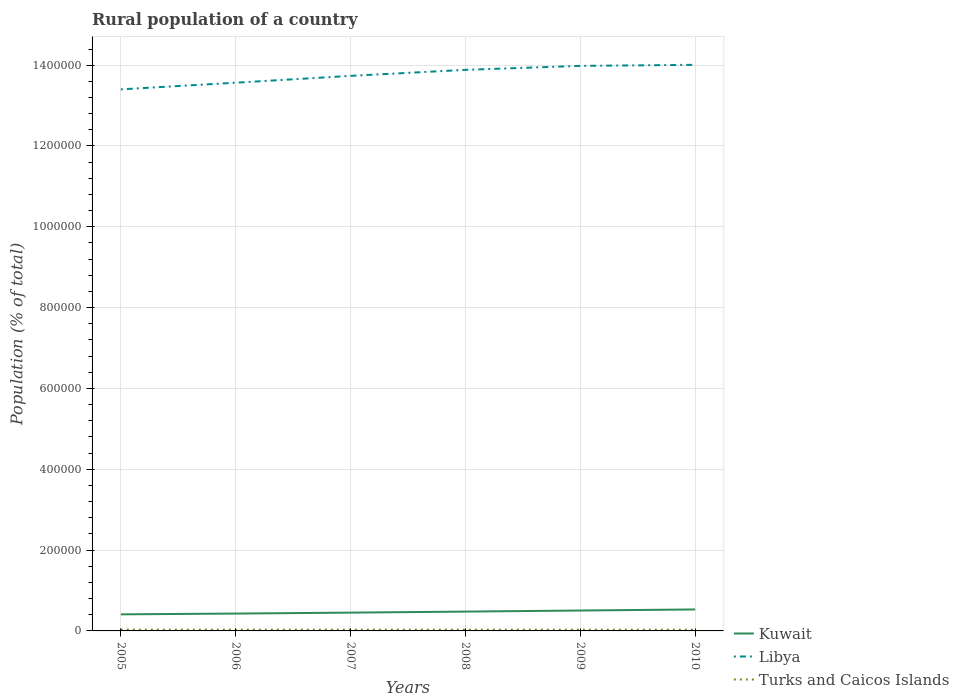How many different coloured lines are there?
Make the answer very short. 3. Is the number of lines equal to the number of legend labels?
Provide a succinct answer. Yes. Across all years, what is the maximum rural population in Libya?
Your answer should be very brief. 1.34e+06. In which year was the rural population in Kuwait maximum?
Your answer should be compact. 2005. What is the total rural population in Libya in the graph?
Your response must be concise. -3.18e+04. What is the difference between the highest and the second highest rural population in Kuwait?
Give a very brief answer. 1.21e+04. What is the difference between the highest and the lowest rural population in Turks and Caicos Islands?
Give a very brief answer. 3. How many lines are there?
Ensure brevity in your answer.  3. How many years are there in the graph?
Make the answer very short. 6. What is the difference between two consecutive major ticks on the Y-axis?
Provide a short and direct response. 2.00e+05. What is the title of the graph?
Give a very brief answer. Rural population of a country. What is the label or title of the X-axis?
Give a very brief answer. Years. What is the label or title of the Y-axis?
Provide a succinct answer. Population (% of total). What is the Population (% of total) in Kuwait in 2005?
Offer a very short reply. 4.10e+04. What is the Population (% of total) in Libya in 2005?
Ensure brevity in your answer.  1.34e+06. What is the Population (% of total) of Turks and Caicos Islands in 2005?
Provide a succinct answer. 3241. What is the Population (% of total) in Kuwait in 2006?
Ensure brevity in your answer.  4.30e+04. What is the Population (% of total) in Libya in 2006?
Keep it short and to the point. 1.36e+06. What is the Population (% of total) in Turks and Caicos Islands in 2006?
Ensure brevity in your answer.  3239. What is the Population (% of total) of Kuwait in 2007?
Give a very brief answer. 4.53e+04. What is the Population (% of total) in Libya in 2007?
Ensure brevity in your answer.  1.37e+06. What is the Population (% of total) in Turks and Caicos Islands in 2007?
Your answer should be very brief. 3208. What is the Population (% of total) of Kuwait in 2008?
Keep it short and to the point. 4.78e+04. What is the Population (% of total) in Libya in 2008?
Your response must be concise. 1.39e+06. What is the Population (% of total) in Turks and Caicos Islands in 2008?
Offer a terse response. 3156. What is the Population (% of total) in Kuwait in 2009?
Your response must be concise. 5.05e+04. What is the Population (% of total) in Libya in 2009?
Provide a succinct answer. 1.40e+06. What is the Population (% of total) in Turks and Caicos Islands in 2009?
Provide a short and direct response. 3094. What is the Population (% of total) of Kuwait in 2010?
Offer a very short reply. 5.31e+04. What is the Population (% of total) of Libya in 2010?
Your response must be concise. 1.40e+06. What is the Population (% of total) in Turks and Caicos Islands in 2010?
Ensure brevity in your answer.  3029. Across all years, what is the maximum Population (% of total) of Kuwait?
Offer a very short reply. 5.31e+04. Across all years, what is the maximum Population (% of total) of Libya?
Your response must be concise. 1.40e+06. Across all years, what is the maximum Population (% of total) in Turks and Caicos Islands?
Your answer should be very brief. 3241. Across all years, what is the minimum Population (% of total) in Kuwait?
Offer a terse response. 4.10e+04. Across all years, what is the minimum Population (% of total) of Libya?
Give a very brief answer. 1.34e+06. Across all years, what is the minimum Population (% of total) of Turks and Caicos Islands?
Ensure brevity in your answer.  3029. What is the total Population (% of total) of Kuwait in the graph?
Your response must be concise. 2.81e+05. What is the total Population (% of total) of Libya in the graph?
Your response must be concise. 8.26e+06. What is the total Population (% of total) in Turks and Caicos Islands in the graph?
Give a very brief answer. 1.90e+04. What is the difference between the Population (% of total) of Kuwait in 2005 and that in 2006?
Your response must be concise. -1924. What is the difference between the Population (% of total) of Libya in 2005 and that in 2006?
Ensure brevity in your answer.  -1.65e+04. What is the difference between the Population (% of total) in Kuwait in 2005 and that in 2007?
Provide a short and direct response. -4224. What is the difference between the Population (% of total) in Libya in 2005 and that in 2007?
Your answer should be compact. -3.34e+04. What is the difference between the Population (% of total) of Kuwait in 2005 and that in 2008?
Give a very brief answer. -6791. What is the difference between the Population (% of total) in Libya in 2005 and that in 2008?
Provide a short and direct response. -4.83e+04. What is the difference between the Population (% of total) in Turks and Caicos Islands in 2005 and that in 2008?
Give a very brief answer. 85. What is the difference between the Population (% of total) in Kuwait in 2005 and that in 2009?
Provide a short and direct response. -9440. What is the difference between the Population (% of total) in Libya in 2005 and that in 2009?
Your answer should be very brief. -5.81e+04. What is the difference between the Population (% of total) in Turks and Caicos Islands in 2005 and that in 2009?
Provide a succinct answer. 147. What is the difference between the Population (% of total) of Kuwait in 2005 and that in 2010?
Provide a short and direct response. -1.21e+04. What is the difference between the Population (% of total) of Libya in 2005 and that in 2010?
Your answer should be compact. -6.07e+04. What is the difference between the Population (% of total) of Turks and Caicos Islands in 2005 and that in 2010?
Offer a terse response. 212. What is the difference between the Population (% of total) in Kuwait in 2006 and that in 2007?
Offer a very short reply. -2300. What is the difference between the Population (% of total) of Libya in 2006 and that in 2007?
Your answer should be very brief. -1.69e+04. What is the difference between the Population (% of total) in Kuwait in 2006 and that in 2008?
Provide a short and direct response. -4867. What is the difference between the Population (% of total) in Libya in 2006 and that in 2008?
Keep it short and to the point. -3.18e+04. What is the difference between the Population (% of total) of Turks and Caicos Islands in 2006 and that in 2008?
Your answer should be very brief. 83. What is the difference between the Population (% of total) of Kuwait in 2006 and that in 2009?
Provide a succinct answer. -7516. What is the difference between the Population (% of total) of Libya in 2006 and that in 2009?
Provide a succinct answer. -4.16e+04. What is the difference between the Population (% of total) in Turks and Caicos Islands in 2006 and that in 2009?
Your answer should be compact. 145. What is the difference between the Population (% of total) of Kuwait in 2006 and that in 2010?
Ensure brevity in your answer.  -1.02e+04. What is the difference between the Population (% of total) in Libya in 2006 and that in 2010?
Offer a terse response. -4.42e+04. What is the difference between the Population (% of total) in Turks and Caicos Islands in 2006 and that in 2010?
Ensure brevity in your answer.  210. What is the difference between the Population (% of total) in Kuwait in 2007 and that in 2008?
Offer a very short reply. -2567. What is the difference between the Population (% of total) in Libya in 2007 and that in 2008?
Your response must be concise. -1.49e+04. What is the difference between the Population (% of total) of Turks and Caicos Islands in 2007 and that in 2008?
Your response must be concise. 52. What is the difference between the Population (% of total) in Kuwait in 2007 and that in 2009?
Make the answer very short. -5216. What is the difference between the Population (% of total) of Libya in 2007 and that in 2009?
Your answer should be very brief. -2.47e+04. What is the difference between the Population (% of total) in Turks and Caicos Islands in 2007 and that in 2009?
Make the answer very short. 114. What is the difference between the Population (% of total) of Kuwait in 2007 and that in 2010?
Ensure brevity in your answer.  -7880. What is the difference between the Population (% of total) of Libya in 2007 and that in 2010?
Keep it short and to the point. -2.73e+04. What is the difference between the Population (% of total) in Turks and Caicos Islands in 2007 and that in 2010?
Provide a short and direct response. 179. What is the difference between the Population (% of total) of Kuwait in 2008 and that in 2009?
Make the answer very short. -2649. What is the difference between the Population (% of total) in Libya in 2008 and that in 2009?
Offer a terse response. -9801. What is the difference between the Population (% of total) of Turks and Caicos Islands in 2008 and that in 2009?
Keep it short and to the point. 62. What is the difference between the Population (% of total) of Kuwait in 2008 and that in 2010?
Offer a very short reply. -5313. What is the difference between the Population (% of total) of Libya in 2008 and that in 2010?
Offer a terse response. -1.24e+04. What is the difference between the Population (% of total) in Turks and Caicos Islands in 2008 and that in 2010?
Offer a very short reply. 127. What is the difference between the Population (% of total) in Kuwait in 2009 and that in 2010?
Offer a terse response. -2664. What is the difference between the Population (% of total) in Libya in 2009 and that in 2010?
Provide a succinct answer. -2628. What is the difference between the Population (% of total) in Kuwait in 2005 and the Population (% of total) in Libya in 2006?
Your answer should be compact. -1.32e+06. What is the difference between the Population (% of total) in Kuwait in 2005 and the Population (% of total) in Turks and Caicos Islands in 2006?
Offer a terse response. 3.78e+04. What is the difference between the Population (% of total) of Libya in 2005 and the Population (% of total) of Turks and Caicos Islands in 2006?
Ensure brevity in your answer.  1.34e+06. What is the difference between the Population (% of total) in Kuwait in 2005 and the Population (% of total) in Libya in 2007?
Offer a terse response. -1.33e+06. What is the difference between the Population (% of total) of Kuwait in 2005 and the Population (% of total) of Turks and Caicos Islands in 2007?
Provide a short and direct response. 3.78e+04. What is the difference between the Population (% of total) in Libya in 2005 and the Population (% of total) in Turks and Caicos Islands in 2007?
Provide a short and direct response. 1.34e+06. What is the difference between the Population (% of total) in Kuwait in 2005 and the Population (% of total) in Libya in 2008?
Offer a very short reply. -1.35e+06. What is the difference between the Population (% of total) in Kuwait in 2005 and the Population (% of total) in Turks and Caicos Islands in 2008?
Keep it short and to the point. 3.79e+04. What is the difference between the Population (% of total) of Libya in 2005 and the Population (% of total) of Turks and Caicos Islands in 2008?
Offer a very short reply. 1.34e+06. What is the difference between the Population (% of total) of Kuwait in 2005 and the Population (% of total) of Libya in 2009?
Provide a succinct answer. -1.36e+06. What is the difference between the Population (% of total) in Kuwait in 2005 and the Population (% of total) in Turks and Caicos Islands in 2009?
Provide a succinct answer. 3.79e+04. What is the difference between the Population (% of total) of Libya in 2005 and the Population (% of total) of Turks and Caicos Islands in 2009?
Provide a succinct answer. 1.34e+06. What is the difference between the Population (% of total) of Kuwait in 2005 and the Population (% of total) of Libya in 2010?
Offer a terse response. -1.36e+06. What is the difference between the Population (% of total) of Kuwait in 2005 and the Population (% of total) of Turks and Caicos Islands in 2010?
Offer a very short reply. 3.80e+04. What is the difference between the Population (% of total) of Libya in 2005 and the Population (% of total) of Turks and Caicos Islands in 2010?
Keep it short and to the point. 1.34e+06. What is the difference between the Population (% of total) in Kuwait in 2006 and the Population (% of total) in Libya in 2007?
Provide a succinct answer. -1.33e+06. What is the difference between the Population (% of total) in Kuwait in 2006 and the Population (% of total) in Turks and Caicos Islands in 2007?
Offer a very short reply. 3.98e+04. What is the difference between the Population (% of total) in Libya in 2006 and the Population (% of total) in Turks and Caicos Islands in 2007?
Offer a very short reply. 1.35e+06. What is the difference between the Population (% of total) of Kuwait in 2006 and the Population (% of total) of Libya in 2008?
Offer a terse response. -1.35e+06. What is the difference between the Population (% of total) in Kuwait in 2006 and the Population (% of total) in Turks and Caicos Islands in 2008?
Offer a terse response. 3.98e+04. What is the difference between the Population (% of total) in Libya in 2006 and the Population (% of total) in Turks and Caicos Islands in 2008?
Your response must be concise. 1.35e+06. What is the difference between the Population (% of total) in Kuwait in 2006 and the Population (% of total) in Libya in 2009?
Your response must be concise. -1.36e+06. What is the difference between the Population (% of total) in Kuwait in 2006 and the Population (% of total) in Turks and Caicos Islands in 2009?
Provide a short and direct response. 3.99e+04. What is the difference between the Population (% of total) in Libya in 2006 and the Population (% of total) in Turks and Caicos Islands in 2009?
Offer a terse response. 1.35e+06. What is the difference between the Population (% of total) in Kuwait in 2006 and the Population (% of total) in Libya in 2010?
Ensure brevity in your answer.  -1.36e+06. What is the difference between the Population (% of total) in Kuwait in 2006 and the Population (% of total) in Turks and Caicos Islands in 2010?
Your answer should be compact. 3.99e+04. What is the difference between the Population (% of total) in Libya in 2006 and the Population (% of total) in Turks and Caicos Islands in 2010?
Your answer should be compact. 1.35e+06. What is the difference between the Population (% of total) of Kuwait in 2007 and the Population (% of total) of Libya in 2008?
Make the answer very short. -1.34e+06. What is the difference between the Population (% of total) in Kuwait in 2007 and the Population (% of total) in Turks and Caicos Islands in 2008?
Offer a very short reply. 4.21e+04. What is the difference between the Population (% of total) of Libya in 2007 and the Population (% of total) of Turks and Caicos Islands in 2008?
Make the answer very short. 1.37e+06. What is the difference between the Population (% of total) in Kuwait in 2007 and the Population (% of total) in Libya in 2009?
Keep it short and to the point. -1.35e+06. What is the difference between the Population (% of total) in Kuwait in 2007 and the Population (% of total) in Turks and Caicos Islands in 2009?
Keep it short and to the point. 4.22e+04. What is the difference between the Population (% of total) in Libya in 2007 and the Population (% of total) in Turks and Caicos Islands in 2009?
Give a very brief answer. 1.37e+06. What is the difference between the Population (% of total) in Kuwait in 2007 and the Population (% of total) in Libya in 2010?
Provide a succinct answer. -1.36e+06. What is the difference between the Population (% of total) in Kuwait in 2007 and the Population (% of total) in Turks and Caicos Islands in 2010?
Your response must be concise. 4.22e+04. What is the difference between the Population (% of total) in Libya in 2007 and the Population (% of total) in Turks and Caicos Islands in 2010?
Offer a terse response. 1.37e+06. What is the difference between the Population (% of total) in Kuwait in 2008 and the Population (% of total) in Libya in 2009?
Keep it short and to the point. -1.35e+06. What is the difference between the Population (% of total) of Kuwait in 2008 and the Population (% of total) of Turks and Caicos Islands in 2009?
Offer a very short reply. 4.47e+04. What is the difference between the Population (% of total) of Libya in 2008 and the Population (% of total) of Turks and Caicos Islands in 2009?
Your answer should be very brief. 1.39e+06. What is the difference between the Population (% of total) of Kuwait in 2008 and the Population (% of total) of Libya in 2010?
Provide a succinct answer. -1.35e+06. What is the difference between the Population (% of total) of Kuwait in 2008 and the Population (% of total) of Turks and Caicos Islands in 2010?
Make the answer very short. 4.48e+04. What is the difference between the Population (% of total) in Libya in 2008 and the Population (% of total) in Turks and Caicos Islands in 2010?
Provide a succinct answer. 1.39e+06. What is the difference between the Population (% of total) of Kuwait in 2009 and the Population (% of total) of Libya in 2010?
Your response must be concise. -1.35e+06. What is the difference between the Population (% of total) in Kuwait in 2009 and the Population (% of total) in Turks and Caicos Islands in 2010?
Ensure brevity in your answer.  4.74e+04. What is the difference between the Population (% of total) of Libya in 2009 and the Population (% of total) of Turks and Caicos Islands in 2010?
Offer a very short reply. 1.40e+06. What is the average Population (% of total) in Kuwait per year?
Make the answer very short. 4.68e+04. What is the average Population (% of total) in Libya per year?
Ensure brevity in your answer.  1.38e+06. What is the average Population (% of total) in Turks and Caicos Islands per year?
Your answer should be compact. 3161.17. In the year 2005, what is the difference between the Population (% of total) in Kuwait and Population (% of total) in Libya?
Make the answer very short. -1.30e+06. In the year 2005, what is the difference between the Population (% of total) of Kuwait and Population (% of total) of Turks and Caicos Islands?
Ensure brevity in your answer.  3.78e+04. In the year 2005, what is the difference between the Population (% of total) in Libya and Population (% of total) in Turks and Caicos Islands?
Your answer should be compact. 1.34e+06. In the year 2006, what is the difference between the Population (% of total) of Kuwait and Population (% of total) of Libya?
Offer a terse response. -1.31e+06. In the year 2006, what is the difference between the Population (% of total) of Kuwait and Population (% of total) of Turks and Caicos Islands?
Provide a succinct answer. 3.97e+04. In the year 2006, what is the difference between the Population (% of total) of Libya and Population (% of total) of Turks and Caicos Islands?
Your answer should be compact. 1.35e+06. In the year 2007, what is the difference between the Population (% of total) of Kuwait and Population (% of total) of Libya?
Your answer should be very brief. -1.33e+06. In the year 2007, what is the difference between the Population (% of total) in Kuwait and Population (% of total) in Turks and Caicos Islands?
Offer a terse response. 4.21e+04. In the year 2007, what is the difference between the Population (% of total) of Libya and Population (% of total) of Turks and Caicos Islands?
Make the answer very short. 1.37e+06. In the year 2008, what is the difference between the Population (% of total) in Kuwait and Population (% of total) in Libya?
Ensure brevity in your answer.  -1.34e+06. In the year 2008, what is the difference between the Population (% of total) in Kuwait and Population (% of total) in Turks and Caicos Islands?
Keep it short and to the point. 4.47e+04. In the year 2008, what is the difference between the Population (% of total) in Libya and Population (% of total) in Turks and Caicos Islands?
Provide a succinct answer. 1.39e+06. In the year 2009, what is the difference between the Population (% of total) in Kuwait and Population (% of total) in Libya?
Ensure brevity in your answer.  -1.35e+06. In the year 2009, what is the difference between the Population (% of total) of Kuwait and Population (% of total) of Turks and Caicos Islands?
Your answer should be compact. 4.74e+04. In the year 2009, what is the difference between the Population (% of total) of Libya and Population (% of total) of Turks and Caicos Islands?
Offer a terse response. 1.40e+06. In the year 2010, what is the difference between the Population (% of total) in Kuwait and Population (% of total) in Libya?
Ensure brevity in your answer.  -1.35e+06. In the year 2010, what is the difference between the Population (% of total) in Kuwait and Population (% of total) in Turks and Caicos Islands?
Your answer should be compact. 5.01e+04. In the year 2010, what is the difference between the Population (% of total) in Libya and Population (% of total) in Turks and Caicos Islands?
Your answer should be compact. 1.40e+06. What is the ratio of the Population (% of total) in Kuwait in 2005 to that in 2006?
Give a very brief answer. 0.96. What is the ratio of the Population (% of total) of Libya in 2005 to that in 2006?
Your response must be concise. 0.99. What is the ratio of the Population (% of total) of Turks and Caicos Islands in 2005 to that in 2006?
Offer a terse response. 1. What is the ratio of the Population (% of total) in Kuwait in 2005 to that in 2007?
Offer a terse response. 0.91. What is the ratio of the Population (% of total) in Libya in 2005 to that in 2007?
Give a very brief answer. 0.98. What is the ratio of the Population (% of total) of Turks and Caicos Islands in 2005 to that in 2007?
Ensure brevity in your answer.  1.01. What is the ratio of the Population (% of total) in Kuwait in 2005 to that in 2008?
Provide a short and direct response. 0.86. What is the ratio of the Population (% of total) in Libya in 2005 to that in 2008?
Offer a very short reply. 0.97. What is the ratio of the Population (% of total) in Turks and Caicos Islands in 2005 to that in 2008?
Make the answer very short. 1.03. What is the ratio of the Population (% of total) in Kuwait in 2005 to that in 2009?
Offer a very short reply. 0.81. What is the ratio of the Population (% of total) in Libya in 2005 to that in 2009?
Offer a terse response. 0.96. What is the ratio of the Population (% of total) in Turks and Caicos Islands in 2005 to that in 2009?
Ensure brevity in your answer.  1.05. What is the ratio of the Population (% of total) of Kuwait in 2005 to that in 2010?
Provide a short and direct response. 0.77. What is the ratio of the Population (% of total) of Libya in 2005 to that in 2010?
Your response must be concise. 0.96. What is the ratio of the Population (% of total) in Turks and Caicos Islands in 2005 to that in 2010?
Offer a very short reply. 1.07. What is the ratio of the Population (% of total) of Kuwait in 2006 to that in 2007?
Your answer should be compact. 0.95. What is the ratio of the Population (% of total) of Turks and Caicos Islands in 2006 to that in 2007?
Your answer should be compact. 1.01. What is the ratio of the Population (% of total) of Kuwait in 2006 to that in 2008?
Your response must be concise. 0.9. What is the ratio of the Population (% of total) in Libya in 2006 to that in 2008?
Your answer should be compact. 0.98. What is the ratio of the Population (% of total) in Turks and Caicos Islands in 2006 to that in 2008?
Your answer should be very brief. 1.03. What is the ratio of the Population (% of total) in Kuwait in 2006 to that in 2009?
Offer a very short reply. 0.85. What is the ratio of the Population (% of total) of Libya in 2006 to that in 2009?
Your answer should be compact. 0.97. What is the ratio of the Population (% of total) of Turks and Caicos Islands in 2006 to that in 2009?
Ensure brevity in your answer.  1.05. What is the ratio of the Population (% of total) in Kuwait in 2006 to that in 2010?
Make the answer very short. 0.81. What is the ratio of the Population (% of total) in Libya in 2006 to that in 2010?
Your response must be concise. 0.97. What is the ratio of the Population (% of total) in Turks and Caicos Islands in 2006 to that in 2010?
Your answer should be compact. 1.07. What is the ratio of the Population (% of total) of Kuwait in 2007 to that in 2008?
Your response must be concise. 0.95. What is the ratio of the Population (% of total) in Libya in 2007 to that in 2008?
Ensure brevity in your answer.  0.99. What is the ratio of the Population (% of total) in Turks and Caicos Islands in 2007 to that in 2008?
Offer a terse response. 1.02. What is the ratio of the Population (% of total) in Kuwait in 2007 to that in 2009?
Your answer should be very brief. 0.9. What is the ratio of the Population (% of total) of Libya in 2007 to that in 2009?
Offer a very short reply. 0.98. What is the ratio of the Population (% of total) in Turks and Caicos Islands in 2007 to that in 2009?
Your answer should be compact. 1.04. What is the ratio of the Population (% of total) of Kuwait in 2007 to that in 2010?
Your response must be concise. 0.85. What is the ratio of the Population (% of total) in Libya in 2007 to that in 2010?
Your response must be concise. 0.98. What is the ratio of the Population (% of total) of Turks and Caicos Islands in 2007 to that in 2010?
Provide a short and direct response. 1.06. What is the ratio of the Population (% of total) of Kuwait in 2008 to that in 2009?
Your answer should be compact. 0.95. What is the ratio of the Population (% of total) in Libya in 2008 to that in 2009?
Make the answer very short. 0.99. What is the ratio of the Population (% of total) of Turks and Caicos Islands in 2008 to that in 2010?
Your response must be concise. 1.04. What is the ratio of the Population (% of total) in Kuwait in 2009 to that in 2010?
Offer a terse response. 0.95. What is the ratio of the Population (% of total) of Libya in 2009 to that in 2010?
Make the answer very short. 1. What is the ratio of the Population (% of total) of Turks and Caicos Islands in 2009 to that in 2010?
Ensure brevity in your answer.  1.02. What is the difference between the highest and the second highest Population (% of total) in Kuwait?
Provide a short and direct response. 2664. What is the difference between the highest and the second highest Population (% of total) of Libya?
Keep it short and to the point. 2628. What is the difference between the highest and the second highest Population (% of total) in Turks and Caicos Islands?
Your answer should be very brief. 2. What is the difference between the highest and the lowest Population (% of total) in Kuwait?
Provide a succinct answer. 1.21e+04. What is the difference between the highest and the lowest Population (% of total) in Libya?
Give a very brief answer. 6.07e+04. What is the difference between the highest and the lowest Population (% of total) of Turks and Caicos Islands?
Provide a succinct answer. 212. 